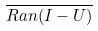Convert formula to latex. <formula><loc_0><loc_0><loc_500><loc_500>\overline { R a n ( I - U ) }</formula> 